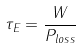<formula> <loc_0><loc_0><loc_500><loc_500>\tau _ { E } = { \frac { W } { P _ { l o s s } } }</formula> 